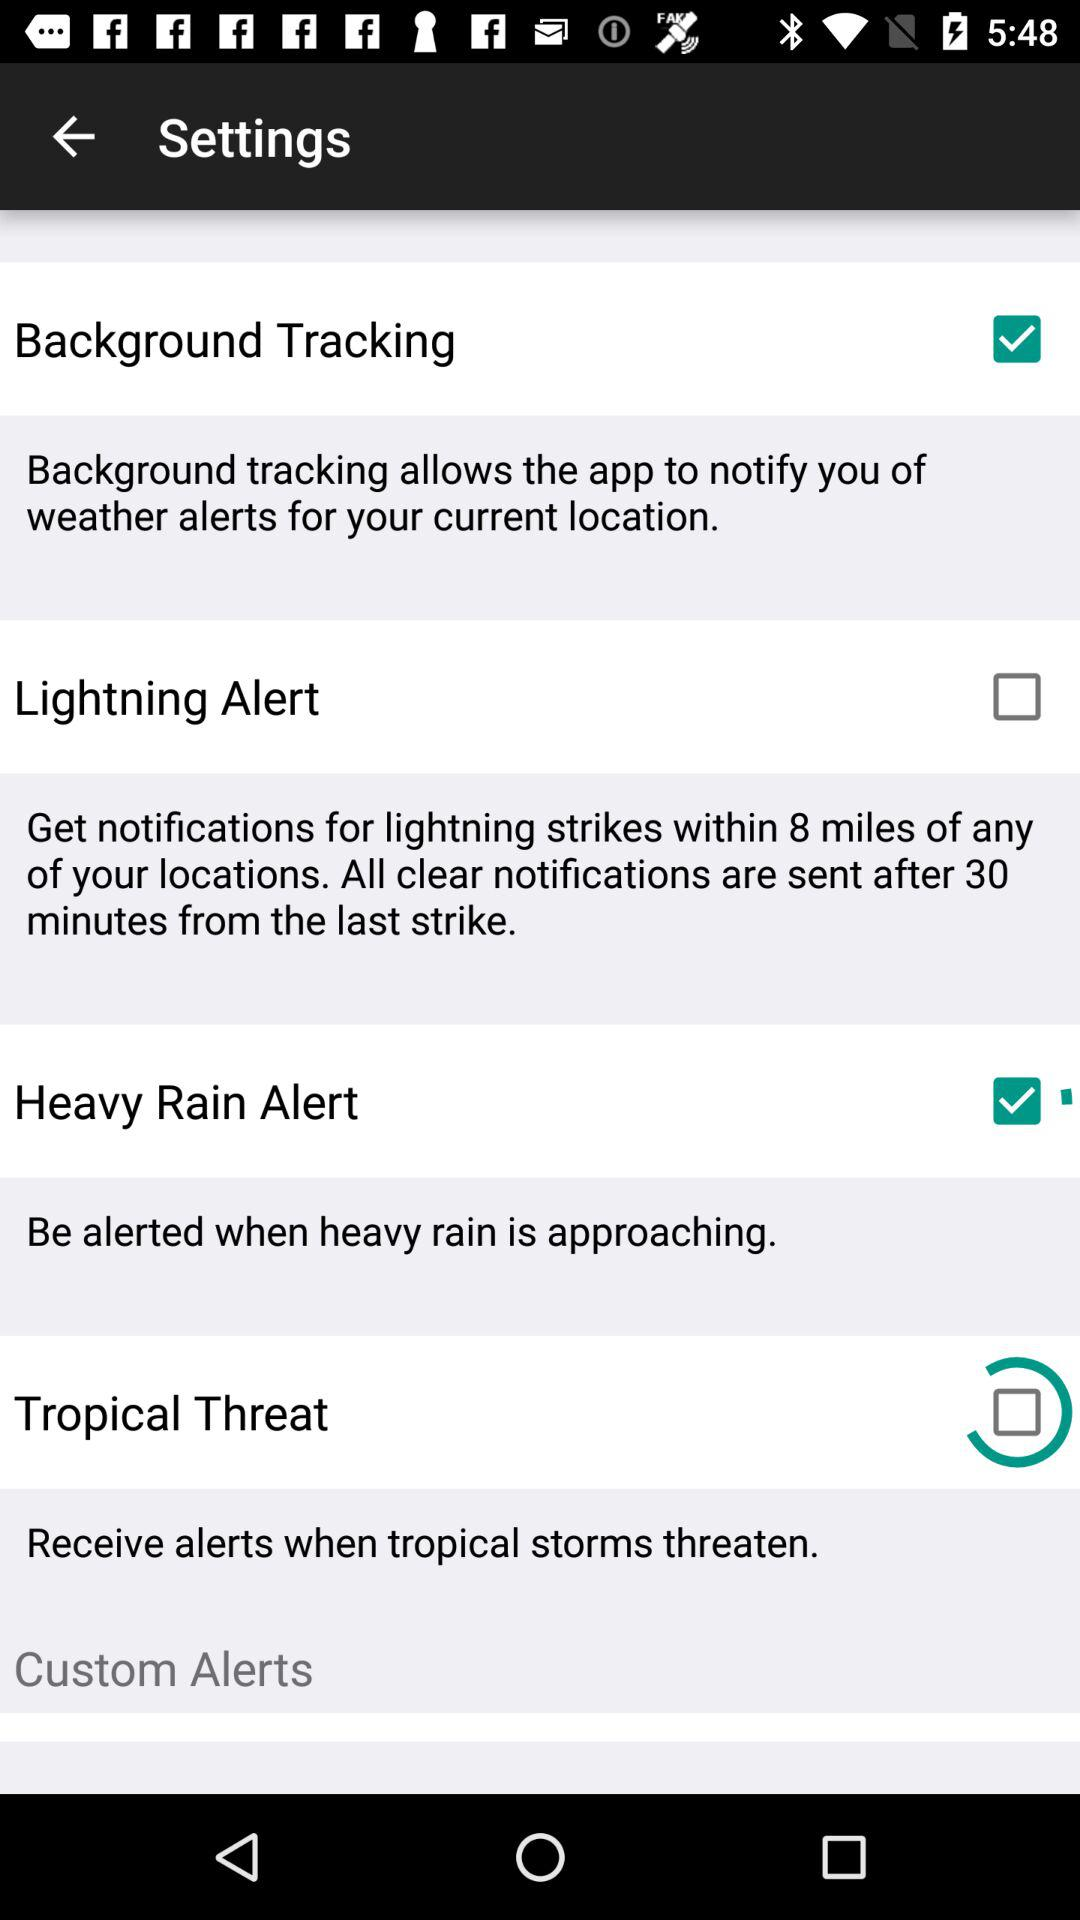Is "Custom Alerts" checked or unchecked?
When the provided information is insufficient, respond with <no answer>. <no answer> 